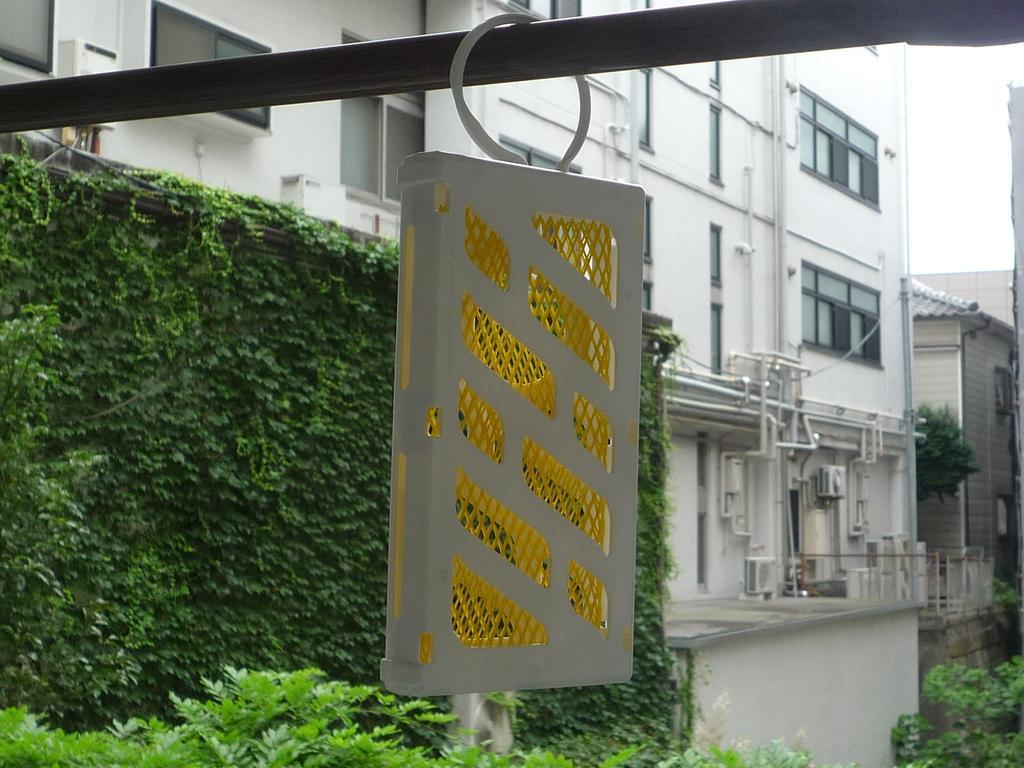Please provide a concise description of this image. In this image, in the middle, we can see a box which is attached to a metal rod. In the background, we can see some trees, plants, buildings, air conditioner, glass window, pipes. At the top, we can see a sky. 